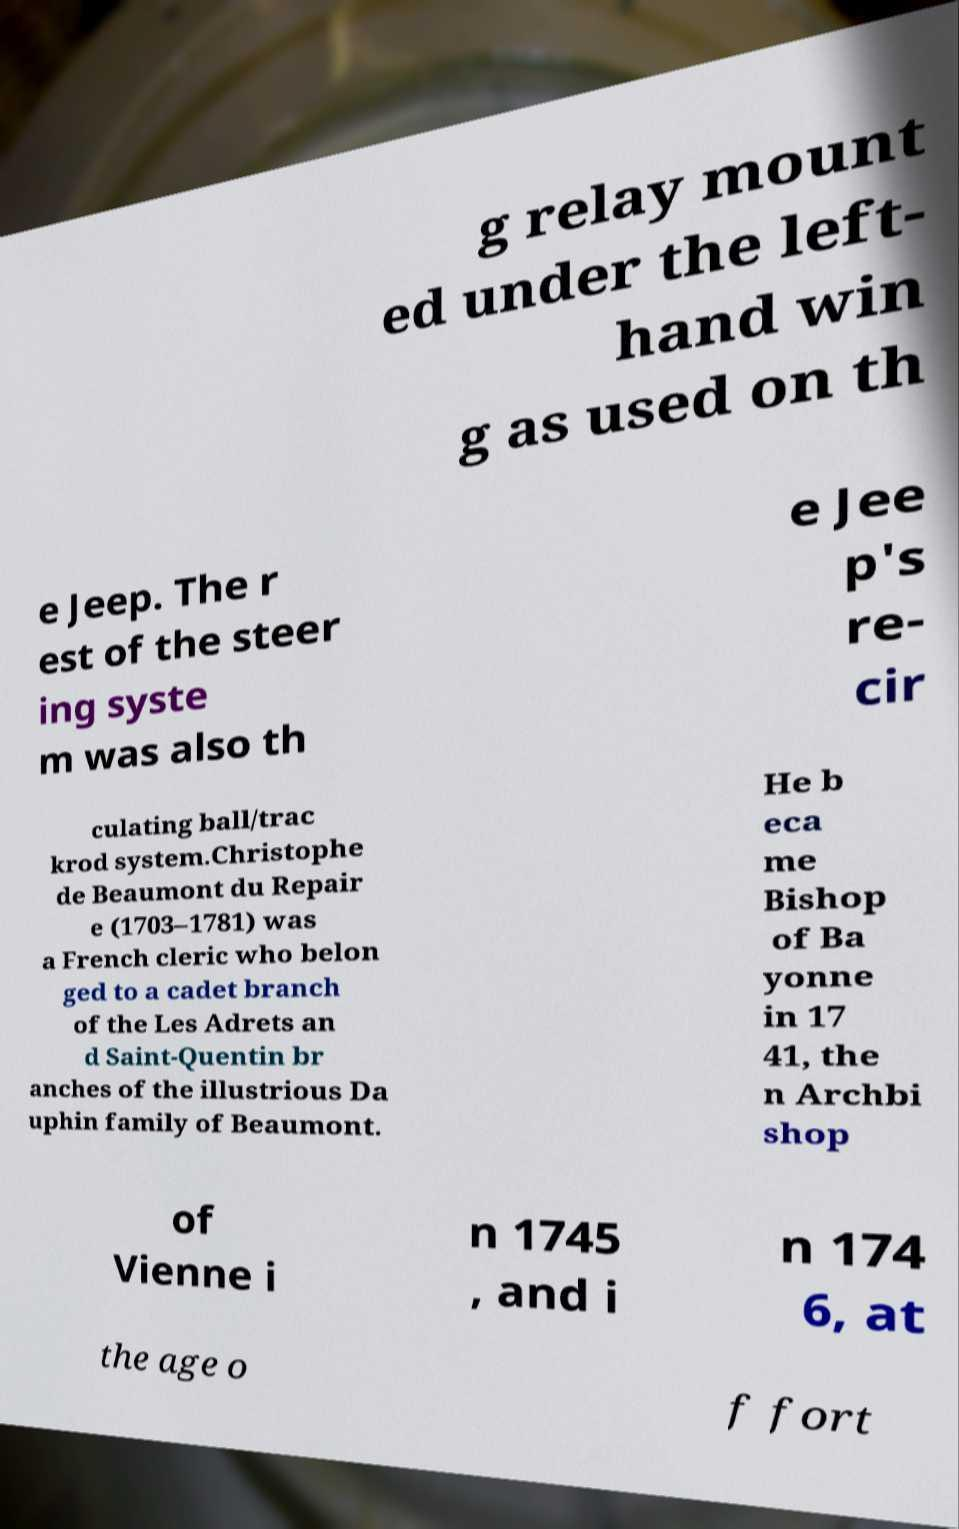What messages or text are displayed in this image? I need them in a readable, typed format. g relay mount ed under the left- hand win g as used on th e Jeep. The r est of the steer ing syste m was also th e Jee p's re- cir culating ball/trac krod system.Christophe de Beaumont du Repair e (1703–1781) was a French cleric who belon ged to a cadet branch of the Les Adrets an d Saint-Quentin br anches of the illustrious Da uphin family of Beaumont. He b eca me Bishop of Ba yonne in 17 41, the n Archbi shop of Vienne i n 1745 , and i n 174 6, at the age o f fort 